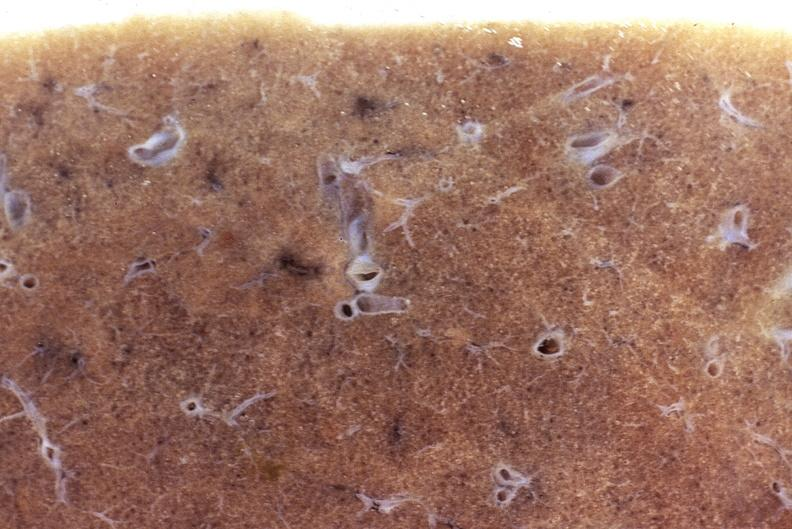what is present?
Answer the question using a single word or phrase. Respiratory 